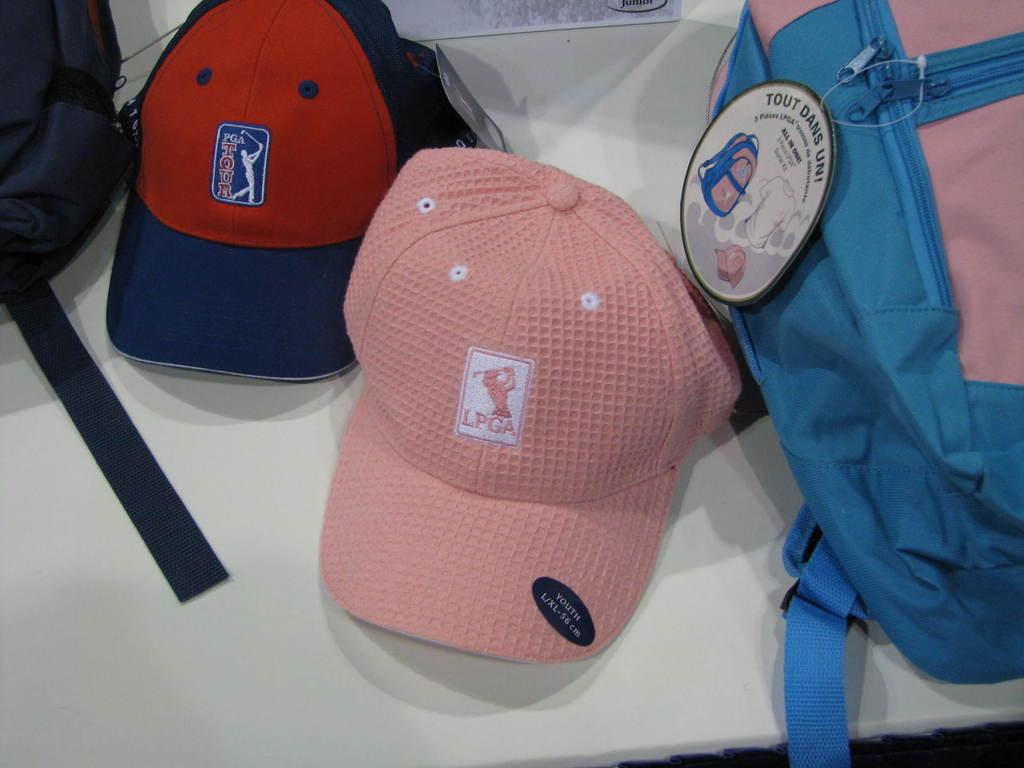<image>
Describe the image concisely. A pink hat with the logo for the LPGA printed on it in white. 